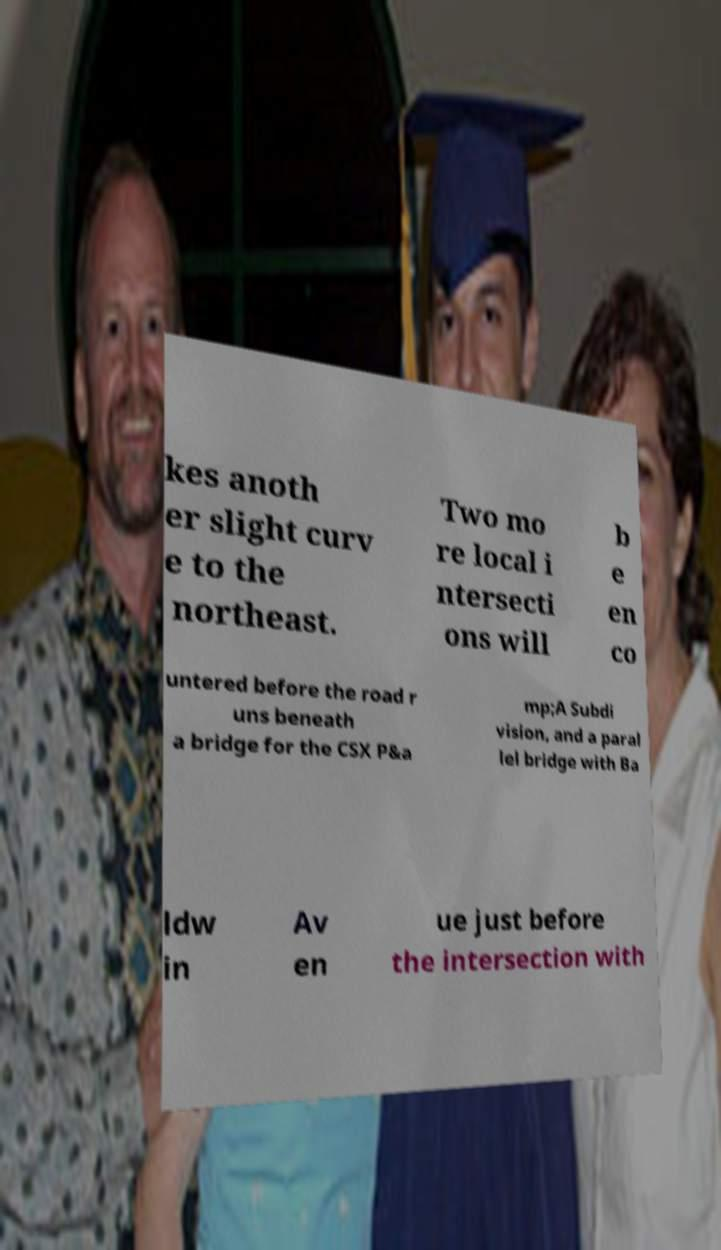Please identify and transcribe the text found in this image. kes anoth er slight curv e to the northeast. Two mo re local i ntersecti ons will b e en co untered before the road r uns beneath a bridge for the CSX P&a mp;A Subdi vision, and a paral lel bridge with Ba ldw in Av en ue just before the intersection with 